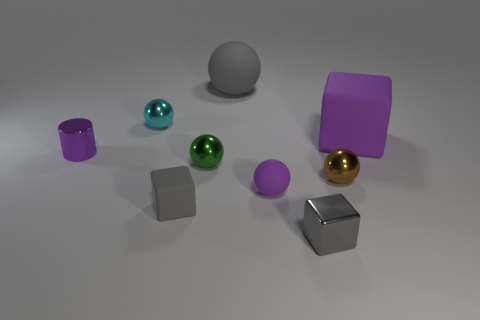Subtract all big matte blocks. How many blocks are left? 2 Subtract all purple cubes. How many cubes are left? 2 Add 1 tiny gray objects. How many objects exist? 10 Subtract all yellow cylinders. How many red blocks are left? 0 Subtract all red things. Subtract all big gray things. How many objects are left? 8 Add 4 tiny shiny cubes. How many tiny shiny cubes are left? 5 Add 2 small metal balls. How many small metal balls exist? 5 Subtract 0 yellow spheres. How many objects are left? 9 Subtract all blocks. How many objects are left? 6 Subtract 3 balls. How many balls are left? 2 